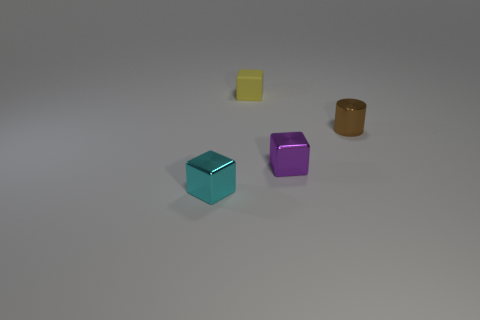Are there fewer big red balls than cyan blocks?
Offer a very short reply. Yes. There is another brown object that is the same size as the rubber thing; what is its material?
Your response must be concise. Metal. What number of objects are large red matte objects or tiny purple things?
Ensure brevity in your answer.  1. How many objects are behind the tiny cyan shiny block and in front of the tiny brown metal object?
Provide a short and direct response. 1. Are there fewer tiny brown cylinders that are behind the cyan cube than yellow matte cubes?
Ensure brevity in your answer.  No. There is a yellow object that is the same size as the brown metal thing; what shape is it?
Provide a short and direct response. Cube. What number of other things are there of the same color as the shiny cylinder?
Keep it short and to the point. 0. How many things are either purple blocks or metal objects left of the small shiny cylinder?
Ensure brevity in your answer.  2. Are there fewer tiny cyan blocks behind the small metallic cylinder than blocks in front of the small yellow matte cube?
Keep it short and to the point. Yes. How many other objects are the same material as the cyan object?
Your answer should be compact. 2. 